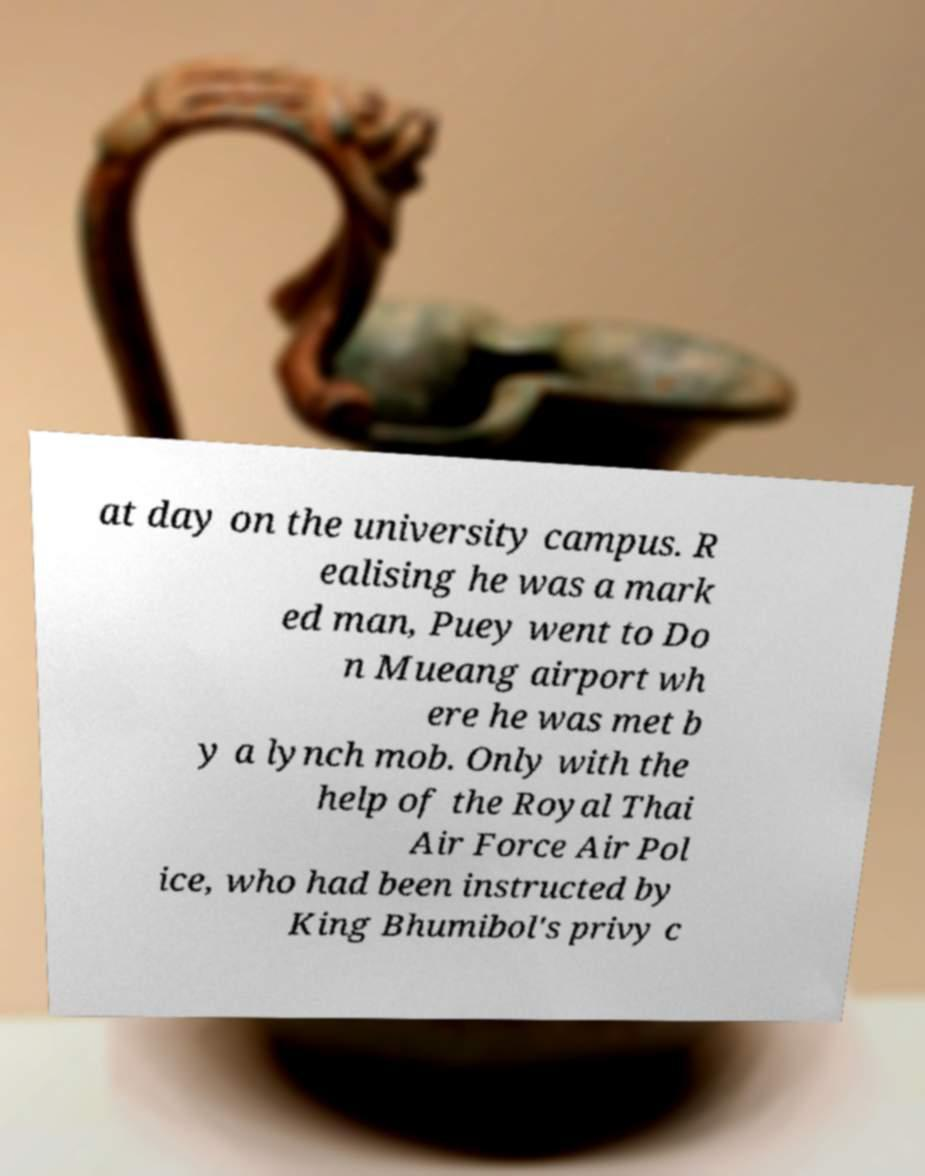Please read and relay the text visible in this image. What does it say? at day on the university campus. R ealising he was a mark ed man, Puey went to Do n Mueang airport wh ere he was met b y a lynch mob. Only with the help of the Royal Thai Air Force Air Pol ice, who had been instructed by King Bhumibol's privy c 